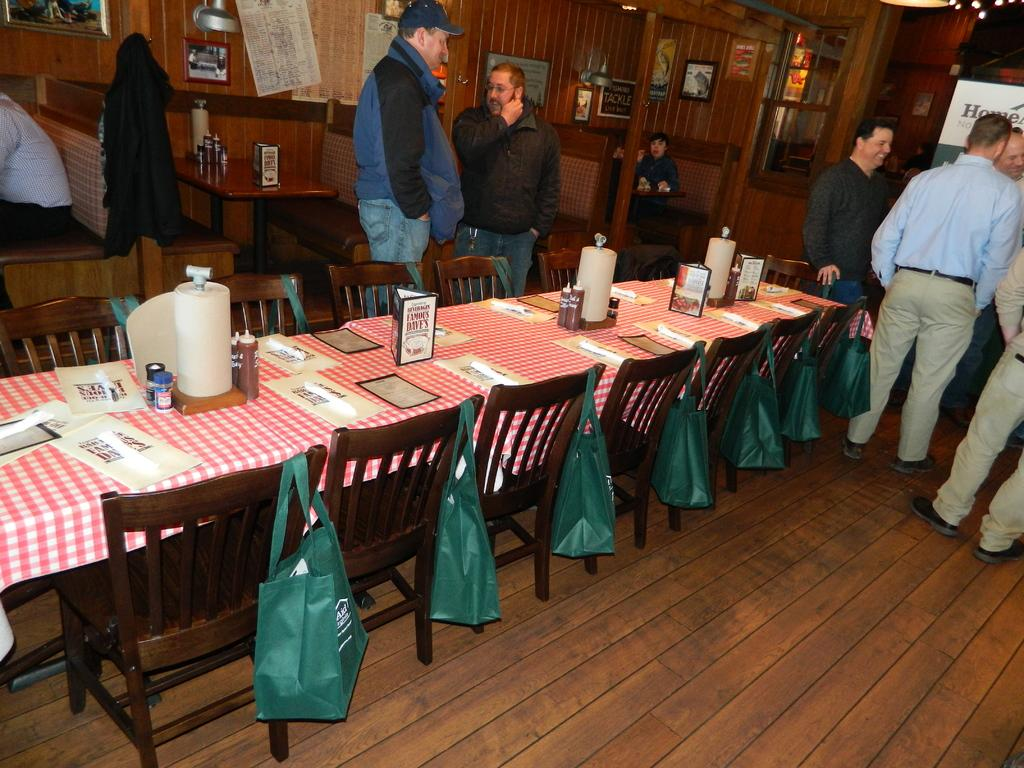What is the main subject of the image? The main subject of the image is a group of people standing. What furniture is present in the image? There are chairs and a table in the image. What type of bags can be seen in the image? There are green bags in the image. Can you hear the finger whistling in the image? There is no finger or whistling present in the image. 